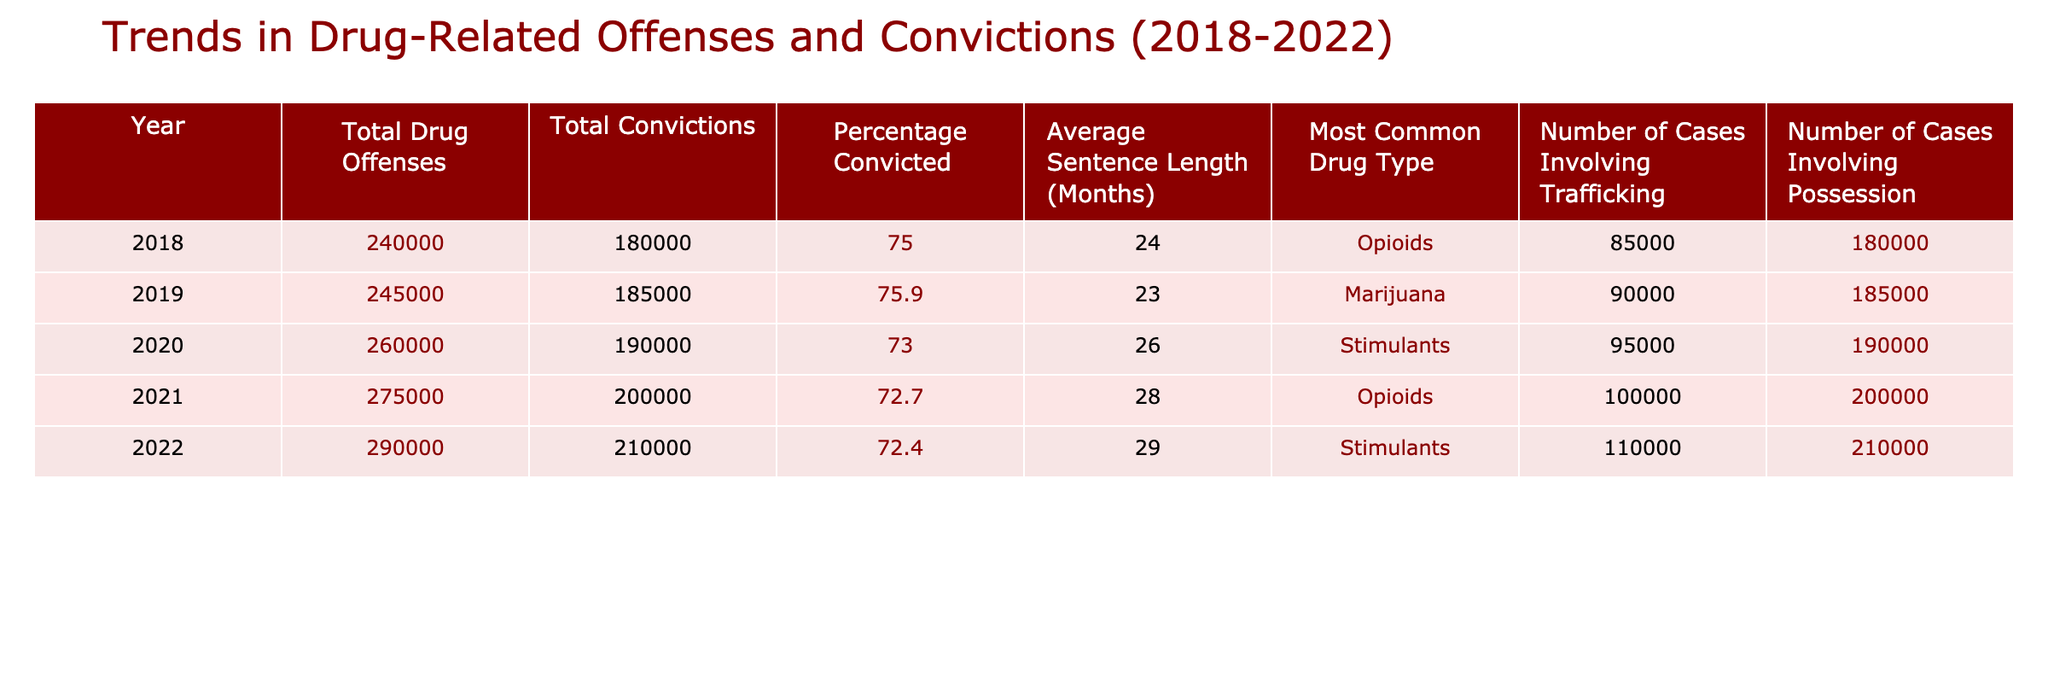What was the total number of drug offenses in 2020? The table shows that the total number of drug offenses in 2020 is specifically listed under that year, which is 260,000.
Answer: 260,000 Which year saw the highest average sentence length? By comparing the average sentence lengths across all years in the table, 2022 has the highest average sentence length of 29 months.
Answer: 29 months What percentage of drug offenses resulted in convictions in 2019? The table specifically states that the percentage convicted in 2019 is 75.9%.
Answer: 75.9% How many more cases involving trafficking were there in 2022 compared to 2018? From the table, the number of trafficking cases in 2022 is 110,000 and in 2018 it was 85,000. The difference is 110,000 - 85,000 = 25,000.
Answer: 25,000 In which year was marijuana the most common drug type? The table lists marijuana as the most common drug type in 2019, as indicated in the corresponding row under the 'Most Common Drug Type' column.
Answer: 2019 Is the number of total convictions increasing each year? By examining the total convictions starting from 2018 through 2022, we can see that the numbers are rising each year: 180,000 in 2018 to 210,000 in 2022, indicating an increase every year.
Answer: Yes What is the average percentage of convictions from 2018 to 2022? To find the average percentage convicted, we sum the percentages for each year: 75 + 75.9 + 73 + 72.7 + 72.4 = 369, then divide by 5, yielding an average of 73.8%.
Answer: 73.8% What trend is observed in the total drug offenses from 2018 to 2022? By reviewing the total drug offenses per year, we see a consistent increase over each year, starting from 240,000 in 2018 and reaching 290,000 in 2022.
Answer: Increasing In which year did stimulant drugs become more common than opioids? Comparing the most common drug types, stimulants replaced opioids starting in 2020, as opioids were most common in 2018 and 2021, but stimulants were listed for 2020 and 2022.
Answer: 2020 What was the total number of cases involving possession in 2021? The table lists the number of cases involving possession in 2021 as 200,000 under that specific year.
Answer: 200,000 